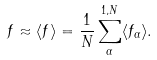Convert formula to latex. <formula><loc_0><loc_0><loc_500><loc_500>f \approx \langle f \rangle = \frac { 1 } { N } \sum _ { \alpha } ^ { 1 , N } \langle f _ { \alpha } \rangle .</formula> 